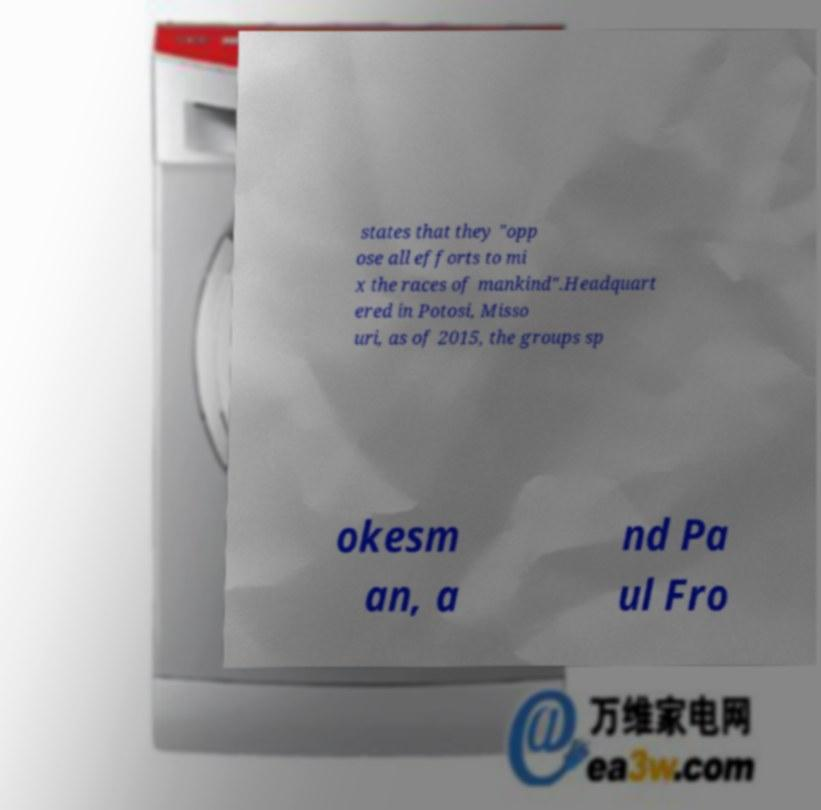Could you extract and type out the text from this image? states that they "opp ose all efforts to mi x the races of mankind".Headquart ered in Potosi, Misso uri, as of 2015, the groups sp okesm an, a nd Pa ul Fro 